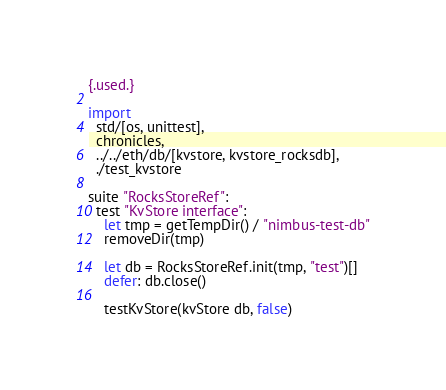Convert code to text. <code><loc_0><loc_0><loc_500><loc_500><_Nim_>{.used.}

import
  std/[os, unittest],
  chronicles,
  ../../eth/db/[kvstore, kvstore_rocksdb],
  ./test_kvstore

suite "RocksStoreRef":
  test "KvStore interface":
    let tmp = getTempDir() / "nimbus-test-db"
    removeDir(tmp)

    let db = RocksStoreRef.init(tmp, "test")[]
    defer: db.close()

    testKvStore(kvStore db, false)
</code> 